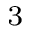<formula> <loc_0><loc_0><loc_500><loc_500>^ { 3 }</formula> 